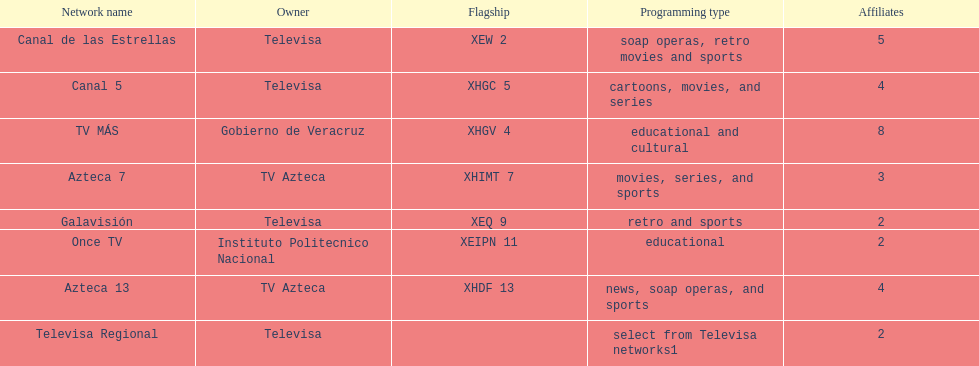What are the different network names under tv azteca? Azteca 7, Azteca 13. 